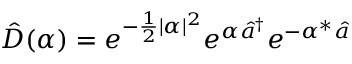<formula> <loc_0><loc_0><loc_500><loc_500>\hat { D } ( \alpha ) = e ^ { - \frac { 1 } { 2 } | \alpha | ^ { 2 } } e ^ { \alpha \hat { a } ^ { \dagger } } e ^ { - \alpha ^ { * } \hat { a } }</formula> 